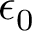<formula> <loc_0><loc_0><loc_500><loc_500>\epsilon _ { 0 }</formula> 